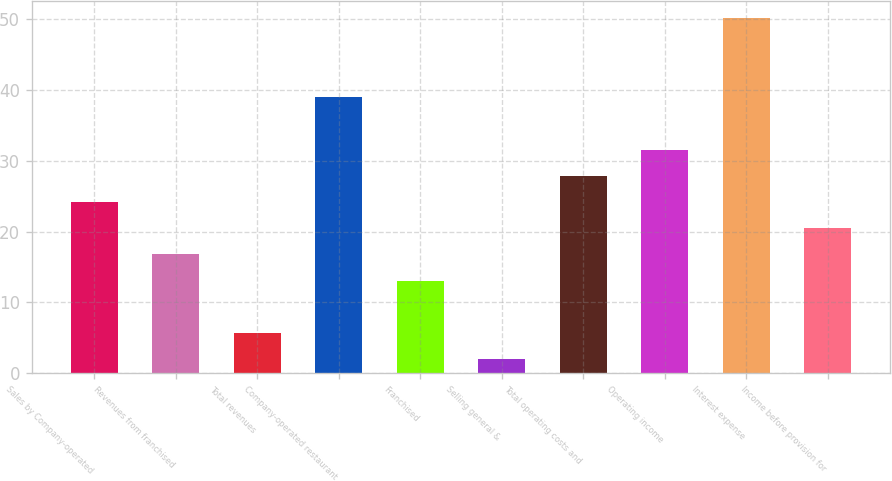<chart> <loc_0><loc_0><loc_500><loc_500><bar_chart><fcel>Sales by Company-operated<fcel>Revenues from franchised<fcel>Total revenues<fcel>Company-operated restaurant<fcel>Franchised<fcel>Selling general &<fcel>Total operating costs and<fcel>Operating income<fcel>Interest expense<fcel>Income before provision for<nl><fcel>24.2<fcel>16.8<fcel>5.7<fcel>39<fcel>13.1<fcel>2<fcel>27.9<fcel>31.6<fcel>50.1<fcel>20.5<nl></chart> 